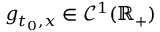<formula> <loc_0><loc_0><loc_500><loc_500>g _ { t _ { 0 } , x } \in \mathcal { C } ^ { 1 } ( \mathbb { R } _ { + } )</formula> 